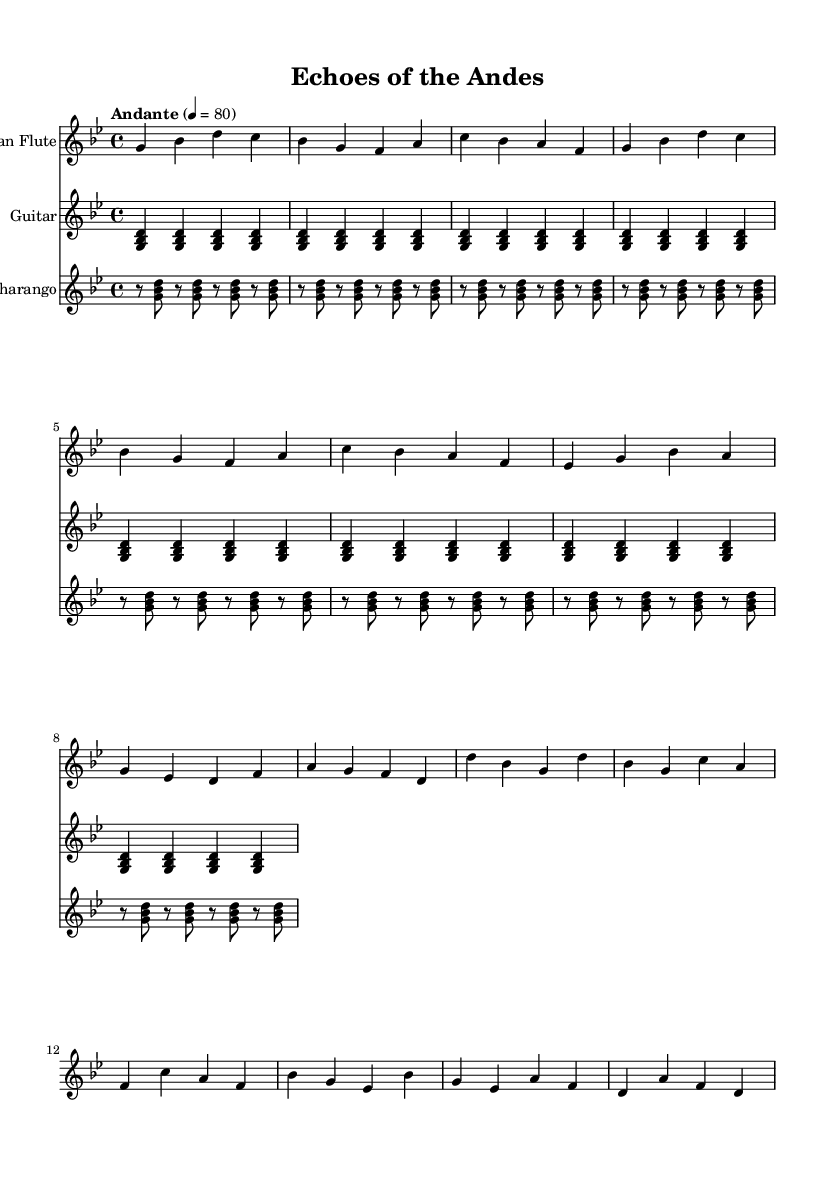What is the key signature of this music? The key signature indicated at the beginning of the music is G minor, which consists of two flats (B♭ and E♭).
Answer: G minor What is the time signature of this music? The time signature at the start shows 4/4, indicating there are four beats in each measure and the quarter note gets one beat.
Answer: 4/4 What is the tempo marking of this piece? The tempo marking specified in the music is "Andante," which typically means a moderately slow tempo, at 80 beats per minute.
Answer: Andante How many measures are in the verse? By counting the measures outlined specifically for the verse section, there are 8 measures present.
Answer: 8 What instruments are present in this arrangement? The music includes three instruments: Pan Flute, Guitar, and Charango, which are all listed at the start of each staff.
Answer: Pan Flute, Guitar, Charango Which section corresponds to the chorus? The section that corresponds to the chorus begins after the verse and can be identified by the unique musical phrases starting with the note D.
Answer: Chorus 